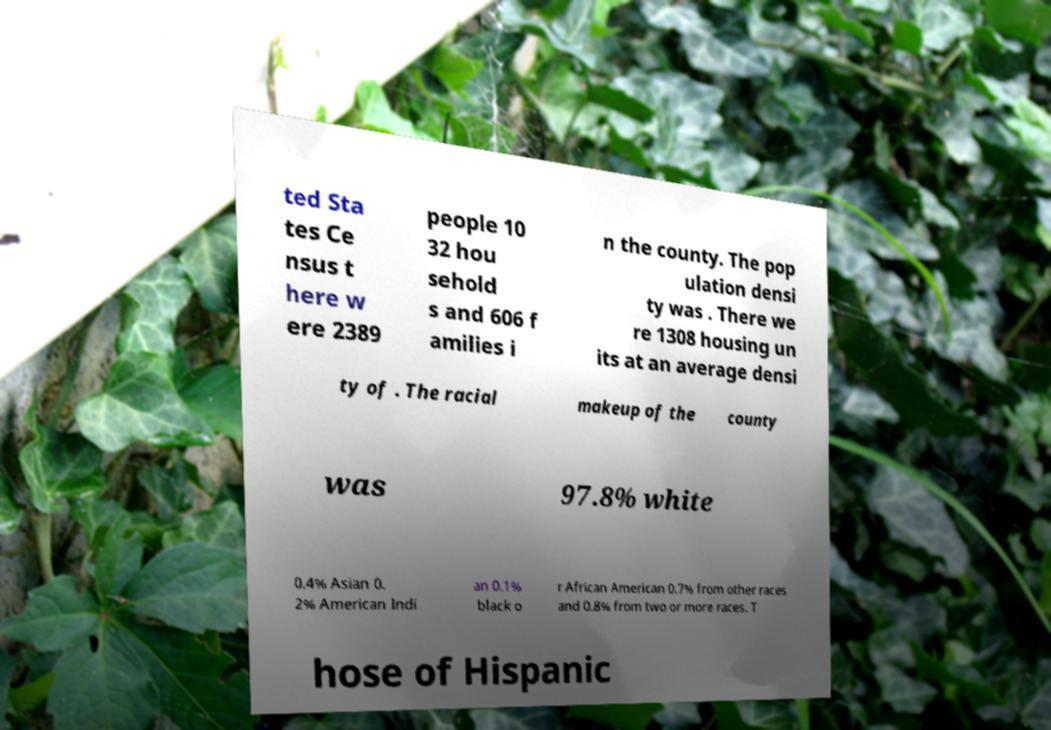There's text embedded in this image that I need extracted. Can you transcribe it verbatim? ted Sta tes Ce nsus t here w ere 2389 people 10 32 hou sehold s and 606 f amilies i n the county. The pop ulation densi ty was . There we re 1308 housing un its at an average densi ty of . The racial makeup of the county was 97.8% white 0.4% Asian 0. 2% American Indi an 0.1% black o r African American 0.7% from other races and 0.8% from two or more races. T hose of Hispanic 